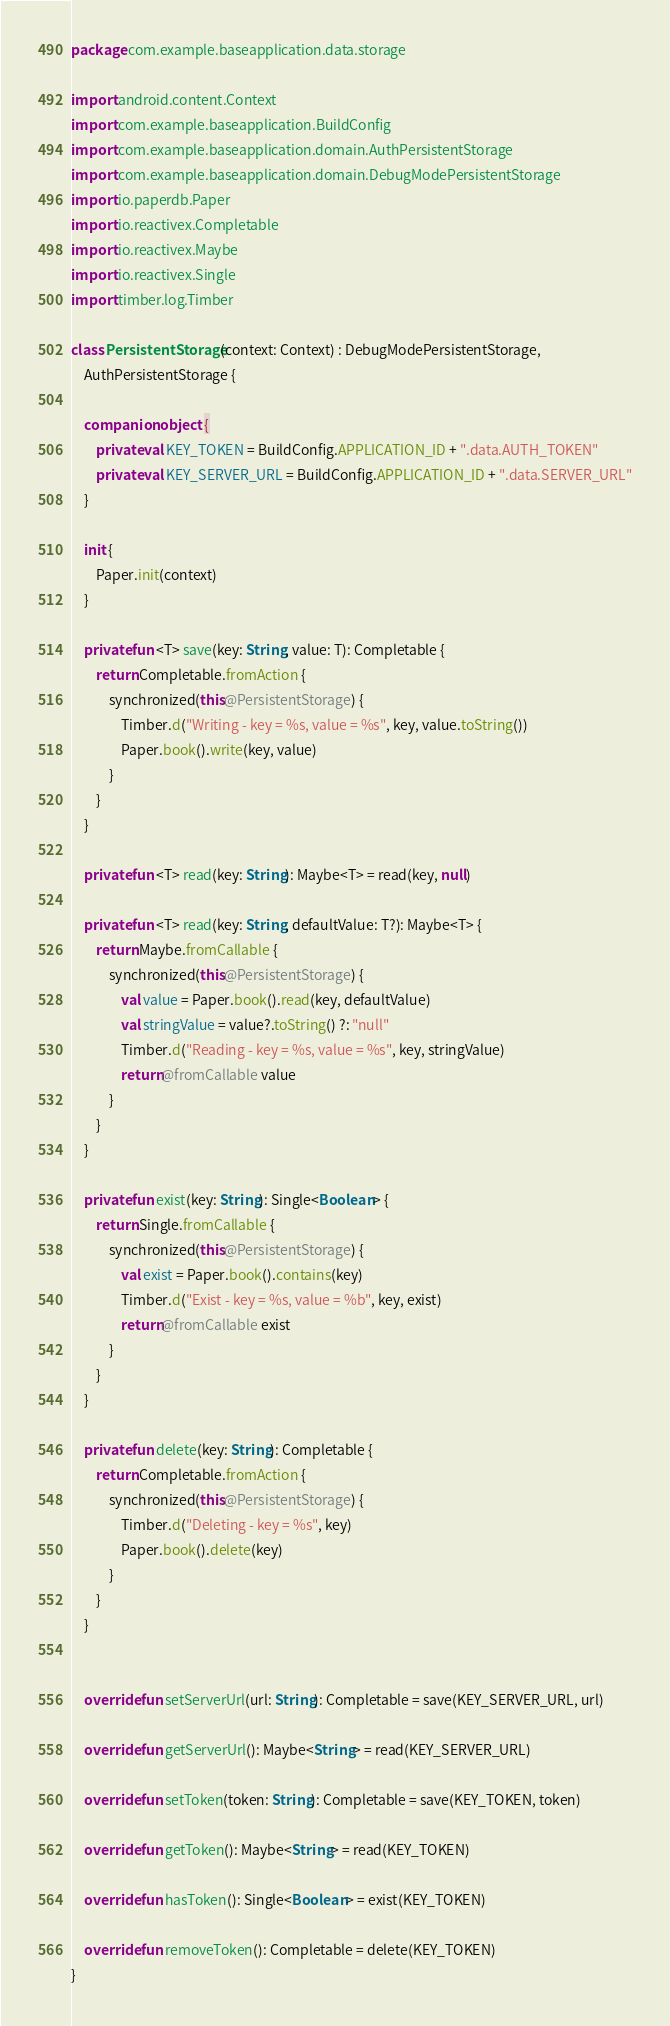<code> <loc_0><loc_0><loc_500><loc_500><_Kotlin_>package com.example.baseapplication.data.storage

import android.content.Context
import com.example.baseapplication.BuildConfig
import com.example.baseapplication.domain.AuthPersistentStorage
import com.example.baseapplication.domain.DebugModePersistentStorage
import io.paperdb.Paper
import io.reactivex.Completable
import io.reactivex.Maybe
import io.reactivex.Single
import timber.log.Timber

class PersistentStorage(context: Context) : DebugModePersistentStorage,
    AuthPersistentStorage {

    companion object {
        private val KEY_TOKEN = BuildConfig.APPLICATION_ID + ".data.AUTH_TOKEN"
        private val KEY_SERVER_URL = BuildConfig.APPLICATION_ID + ".data.SERVER_URL"
    }

    init {
        Paper.init(context)
    }

    private fun <T> save(key: String, value: T): Completable {
        return Completable.fromAction {
            synchronized(this@PersistentStorage) {
                Timber.d("Writing - key = %s, value = %s", key, value.toString())
                Paper.book().write(key, value)
            }
        }
    }

    private fun <T> read(key: String): Maybe<T> = read(key, null)

    private fun <T> read(key: String, defaultValue: T?): Maybe<T> {
        return Maybe.fromCallable {
            synchronized(this@PersistentStorage) {
                val value = Paper.book().read(key, defaultValue)
                val stringValue = value?.toString() ?: "null"
                Timber.d("Reading - key = %s, value = %s", key, stringValue)
                return@fromCallable value
            }
        }
    }

    private fun exist(key: String): Single<Boolean> {
        return Single.fromCallable {
            synchronized(this@PersistentStorage) {
                val exist = Paper.book().contains(key)
                Timber.d("Exist - key = %s, value = %b", key, exist)
                return@fromCallable exist
            }
        }
    }

    private fun delete(key: String): Completable {
        return Completable.fromAction {
            synchronized(this@PersistentStorage) {
                Timber.d("Deleting - key = %s", key)
                Paper.book().delete(key)
            }
        }
    }


    override fun setServerUrl(url: String): Completable = save(KEY_SERVER_URL, url)

    override fun getServerUrl(): Maybe<String> = read(KEY_SERVER_URL)

    override fun setToken(token: String): Completable = save(KEY_TOKEN, token)

    override fun getToken(): Maybe<String> = read(KEY_TOKEN)

    override fun hasToken(): Single<Boolean> = exist(KEY_TOKEN)

    override fun removeToken(): Completable = delete(KEY_TOKEN)
}
</code> 